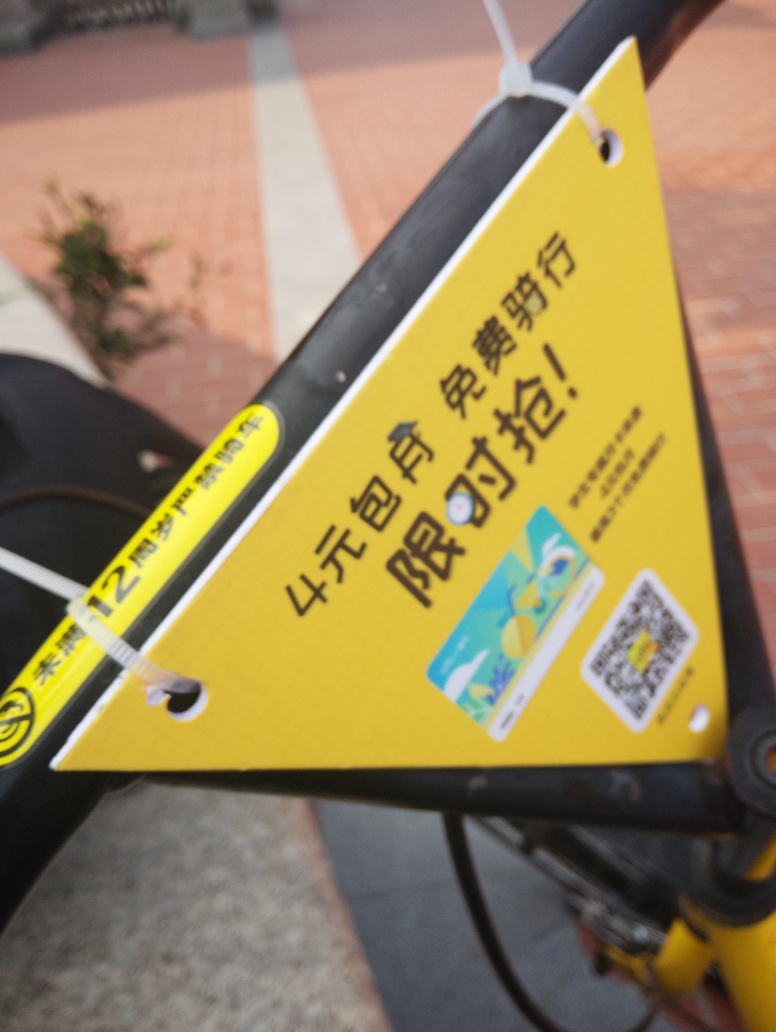What kind of setting does this picture suggest? The photo seems to be taken outdoors due to the daylight and shadows on the ground. The presence of what looks like paving suggests an urban or suburban setting potentially a public area where a sign or notice might be posted, perhaps on a bicycle or a post considering the metal part in the foreground. 